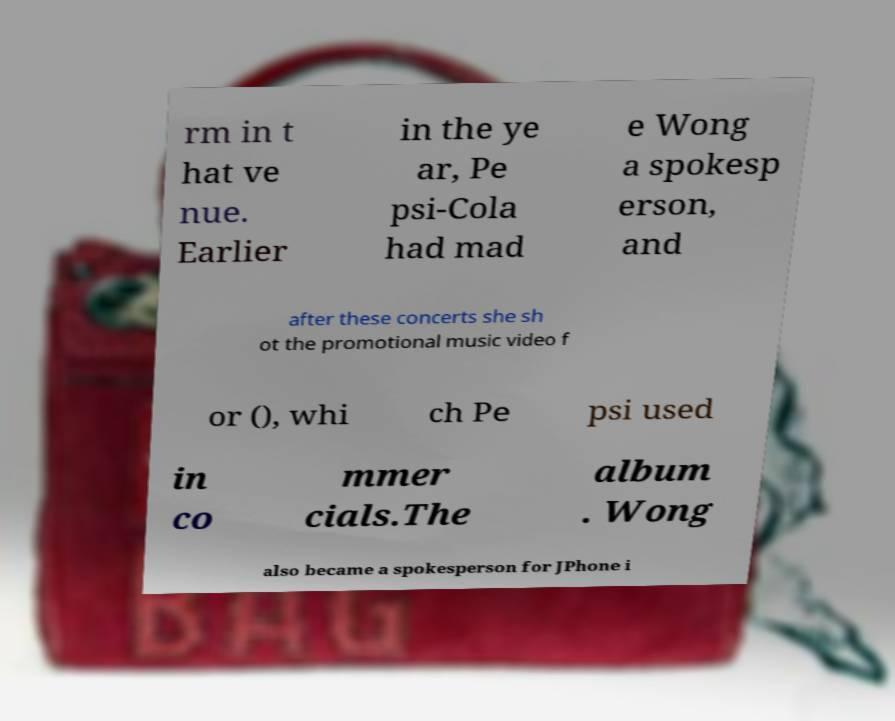Please identify and transcribe the text found in this image. rm in t hat ve nue. Earlier in the ye ar, Pe psi-Cola had mad e Wong a spokesp erson, and after these concerts she sh ot the promotional music video f or (), whi ch Pe psi used in co mmer cials.The album . Wong also became a spokesperson for JPhone i 